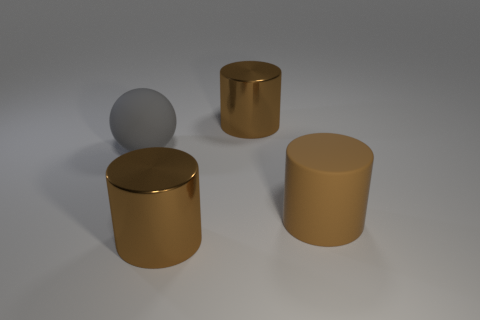Is the number of big matte spheres on the right side of the large brown matte cylinder less than the number of tiny blue rubber objects?
Your answer should be compact. No. Do the gray thing and the brown matte cylinder have the same size?
Your answer should be very brief. Yes. Is there any other thing that is the same size as the brown matte object?
Keep it short and to the point. Yes. What is the color of the large cylinder that is made of the same material as the gray object?
Make the answer very short. Brown. Is the number of shiny cylinders in front of the big gray sphere less than the number of large cylinders in front of the matte cylinder?
Give a very brief answer. No. How many metal things are the same color as the big rubber cylinder?
Keep it short and to the point. 2. What number of big cylinders are both on the left side of the large matte cylinder and in front of the big sphere?
Your answer should be very brief. 1. The large cylinder to the left of the shiny object that is behind the large brown matte cylinder is made of what material?
Provide a succinct answer. Metal. Are there any cylinders that have the same material as the ball?
Provide a succinct answer. Yes. What material is the ball that is the same size as the brown matte cylinder?
Keep it short and to the point. Rubber. 